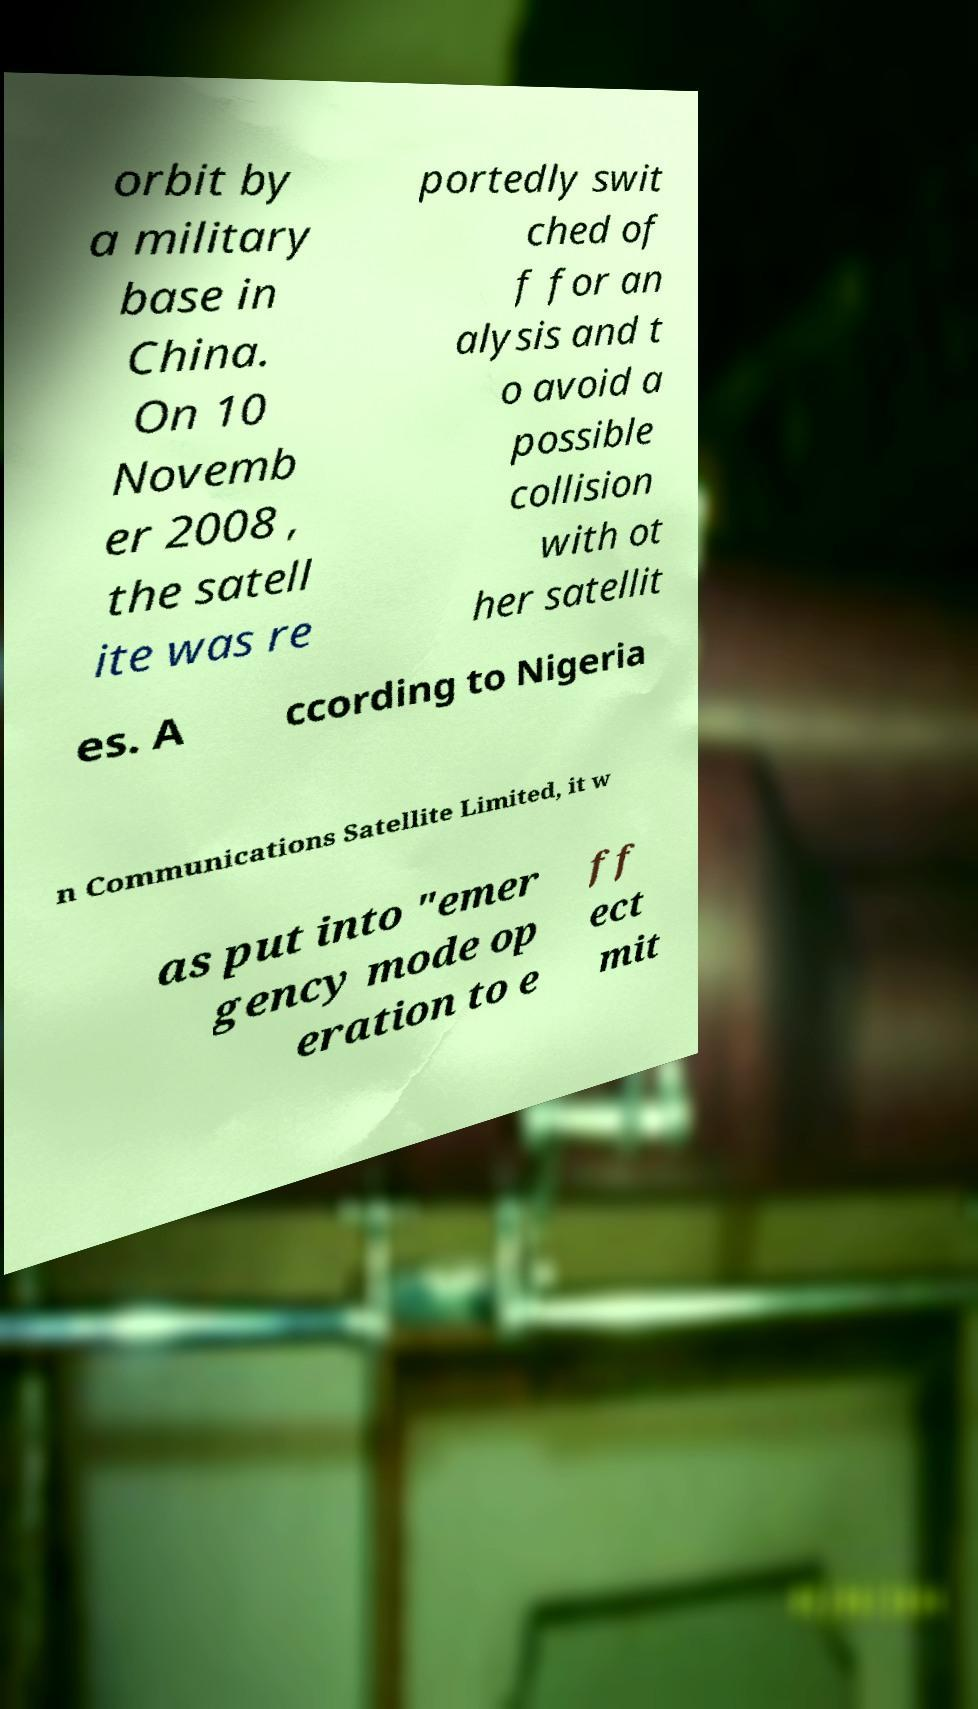For documentation purposes, I need the text within this image transcribed. Could you provide that? orbit by a military base in China. On 10 Novemb er 2008 , the satell ite was re portedly swit ched of f for an alysis and t o avoid a possible collision with ot her satellit es. A ccording to Nigeria n Communications Satellite Limited, it w as put into "emer gency mode op eration to e ff ect mit 